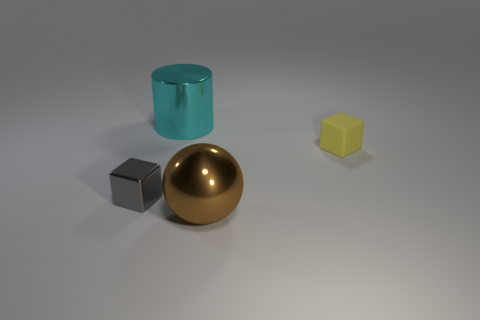Subtract 2 blocks. How many blocks are left? 0 Add 1 cyan objects. How many cyan objects exist? 2 Add 3 big metal cylinders. How many objects exist? 7 Subtract 0 cyan cubes. How many objects are left? 4 Subtract all spheres. How many objects are left? 3 Subtract all blue cylinders. Subtract all yellow spheres. How many cylinders are left? 1 Subtract all red cubes. How many blue cylinders are left? 0 Subtract all small blue things. Subtract all large brown spheres. How many objects are left? 3 Add 4 tiny gray blocks. How many tiny gray blocks are left? 5 